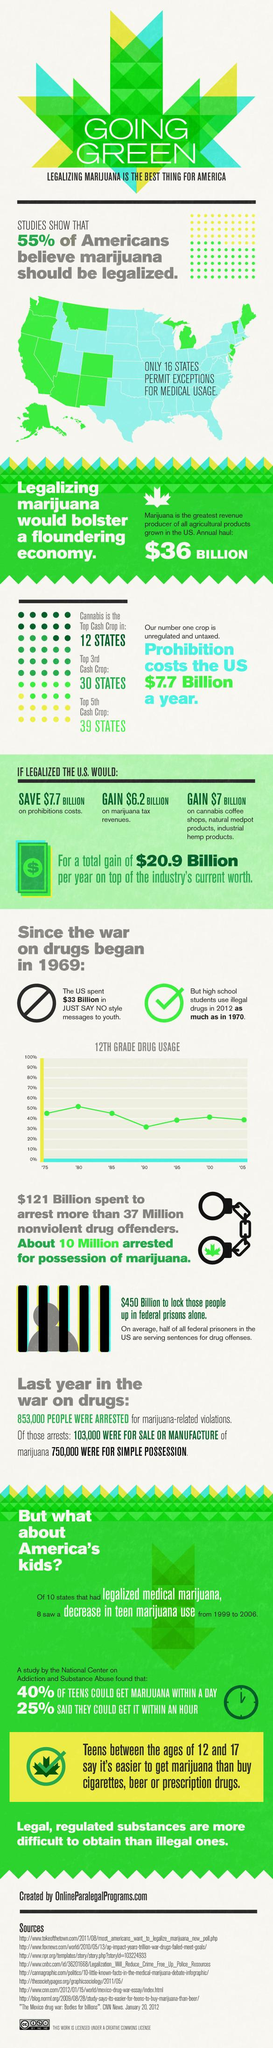Mention a couple of crucial points in this snapshot. A majority of Americans, at 45%, do not believe that marijuana should be legalized. If marijuana is legalized in the United States, the country could potentially save $7.7 billion on prohibition costs. The revenue earned from marijuana in the United States is estimated to be approximately $36 billion annually. The potential profit from marijuana tax revenues in the United States would be approximately $6.2 BILLION if it were legalized. 